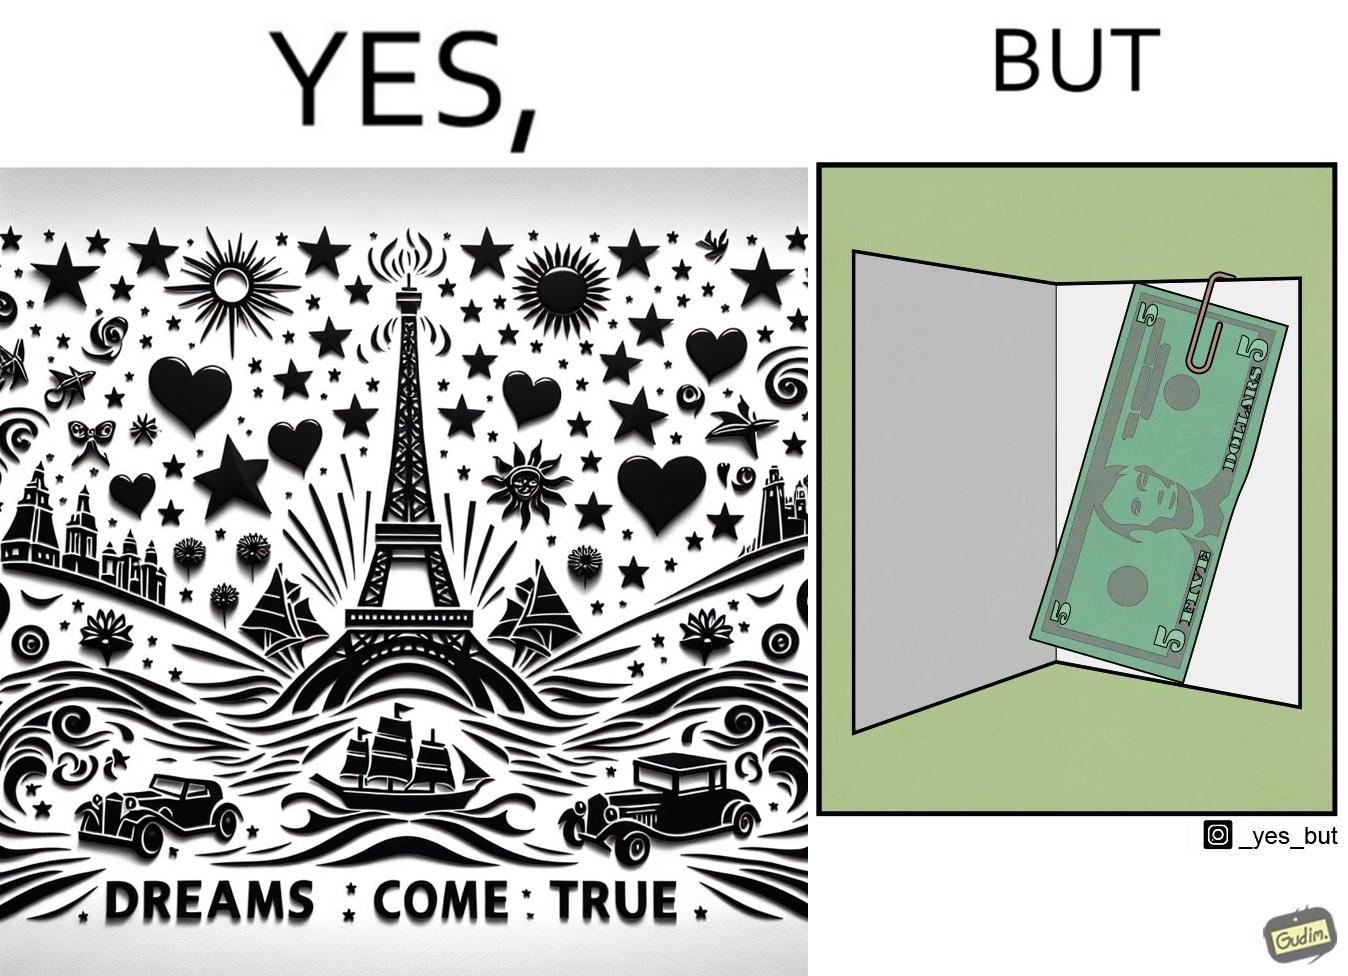Is this a satirical image? Yes, this image is satirical. 